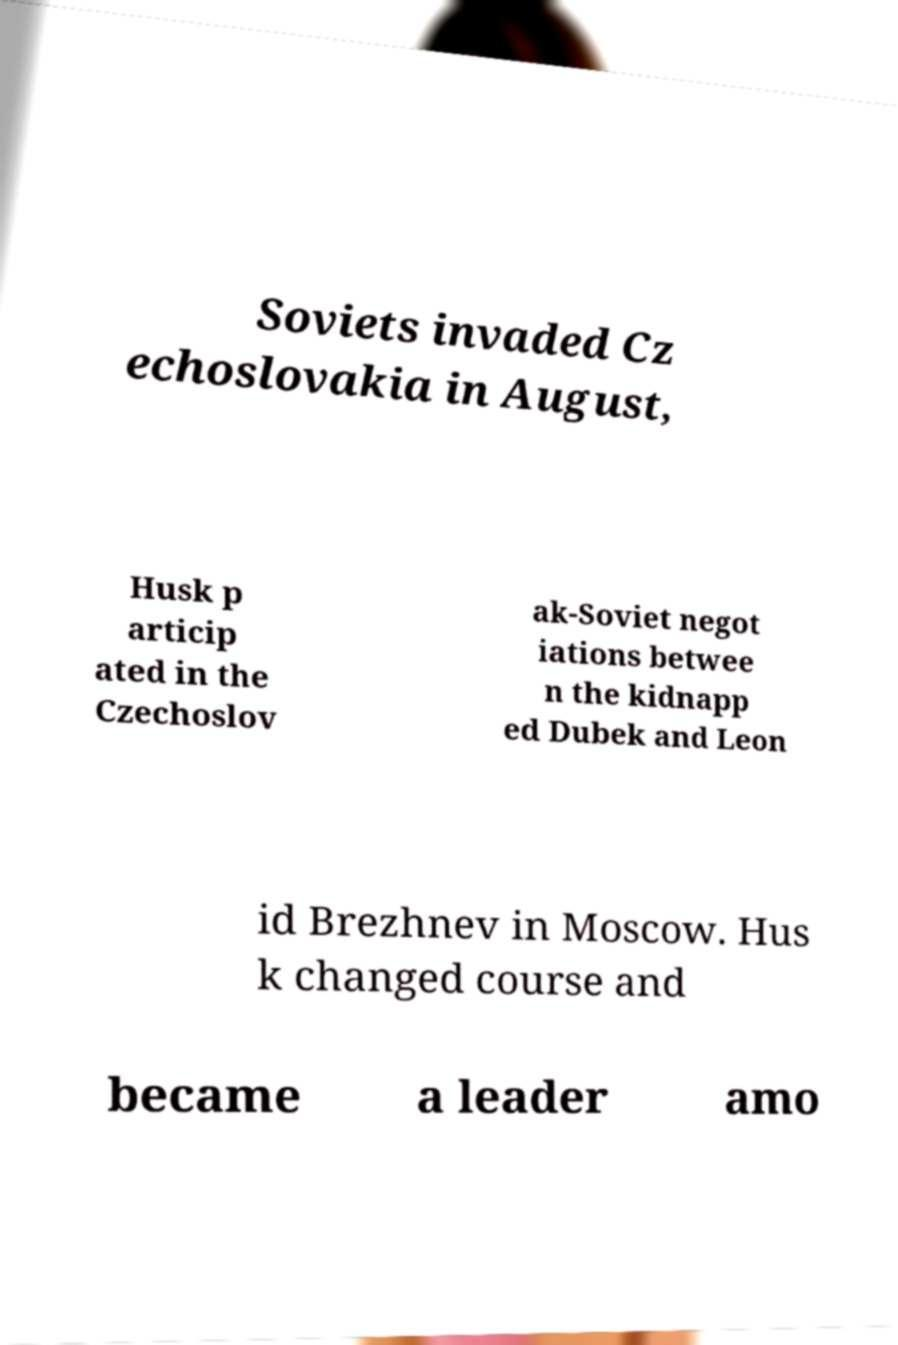Can you accurately transcribe the text from the provided image for me? Soviets invaded Cz echoslovakia in August, Husk p articip ated in the Czechoslov ak-Soviet negot iations betwee n the kidnapp ed Dubek and Leon id Brezhnev in Moscow. Hus k changed course and became a leader amo 